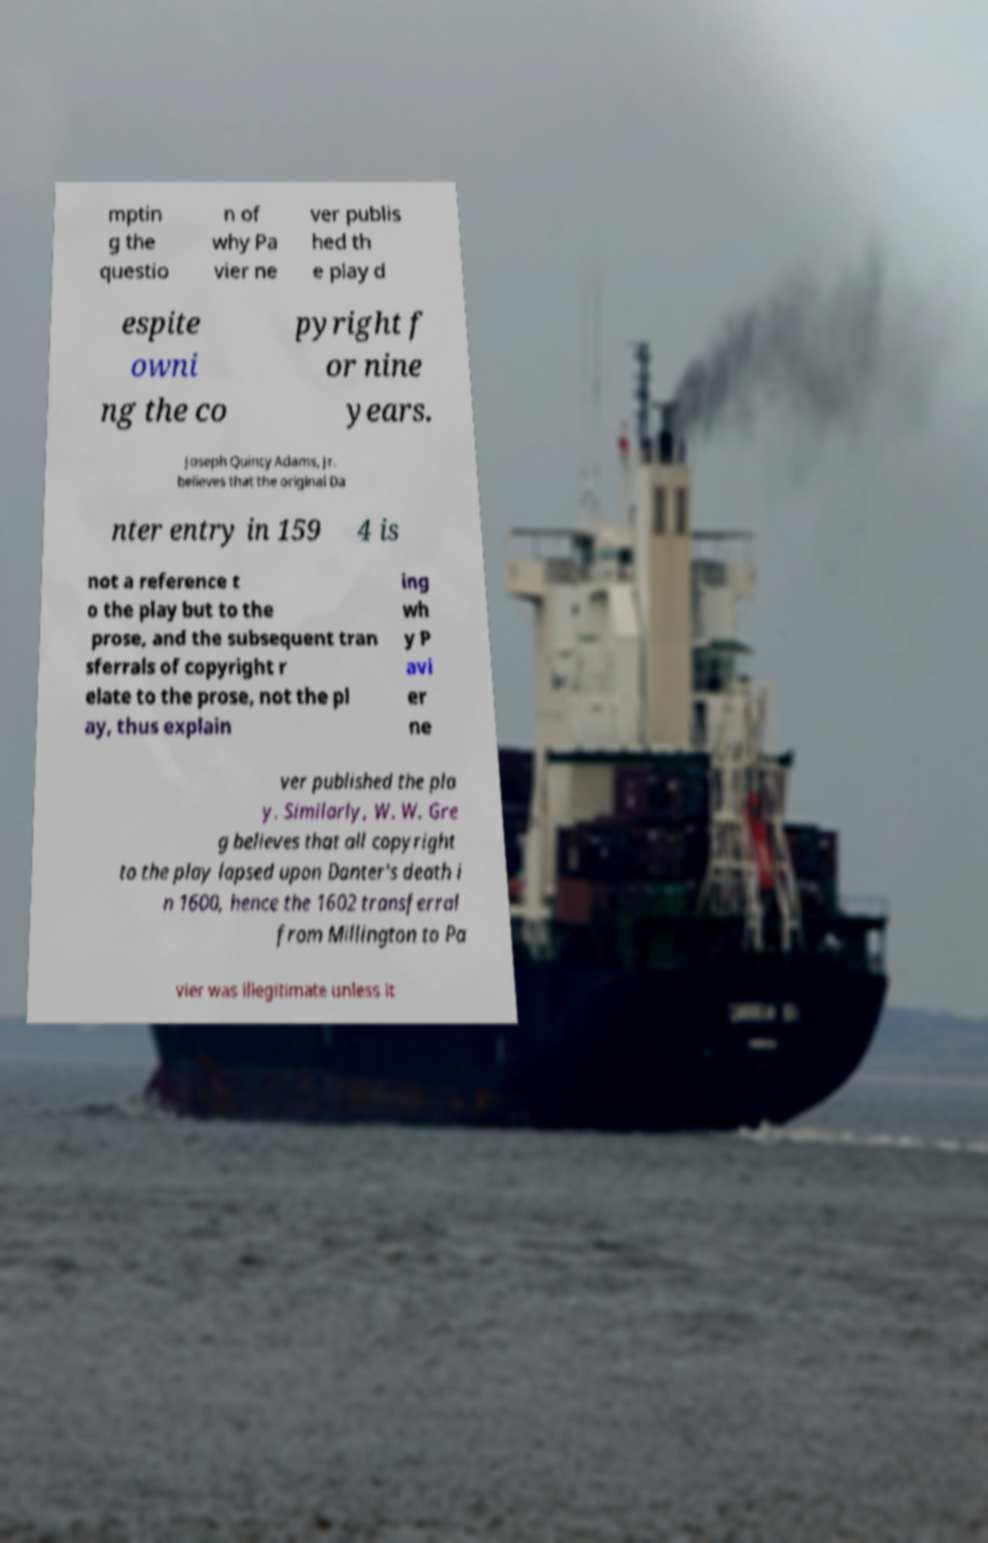Please identify and transcribe the text found in this image. mptin g the questio n of why Pa vier ne ver publis hed th e play d espite owni ng the co pyright f or nine years. Joseph Quincy Adams, Jr. believes that the original Da nter entry in 159 4 is not a reference t o the play but to the prose, and the subsequent tran sferrals of copyright r elate to the prose, not the pl ay, thus explain ing wh y P avi er ne ver published the pla y. Similarly, W. W. Gre g believes that all copyright to the play lapsed upon Danter's death i n 1600, hence the 1602 transferral from Millington to Pa vier was illegitimate unless it 